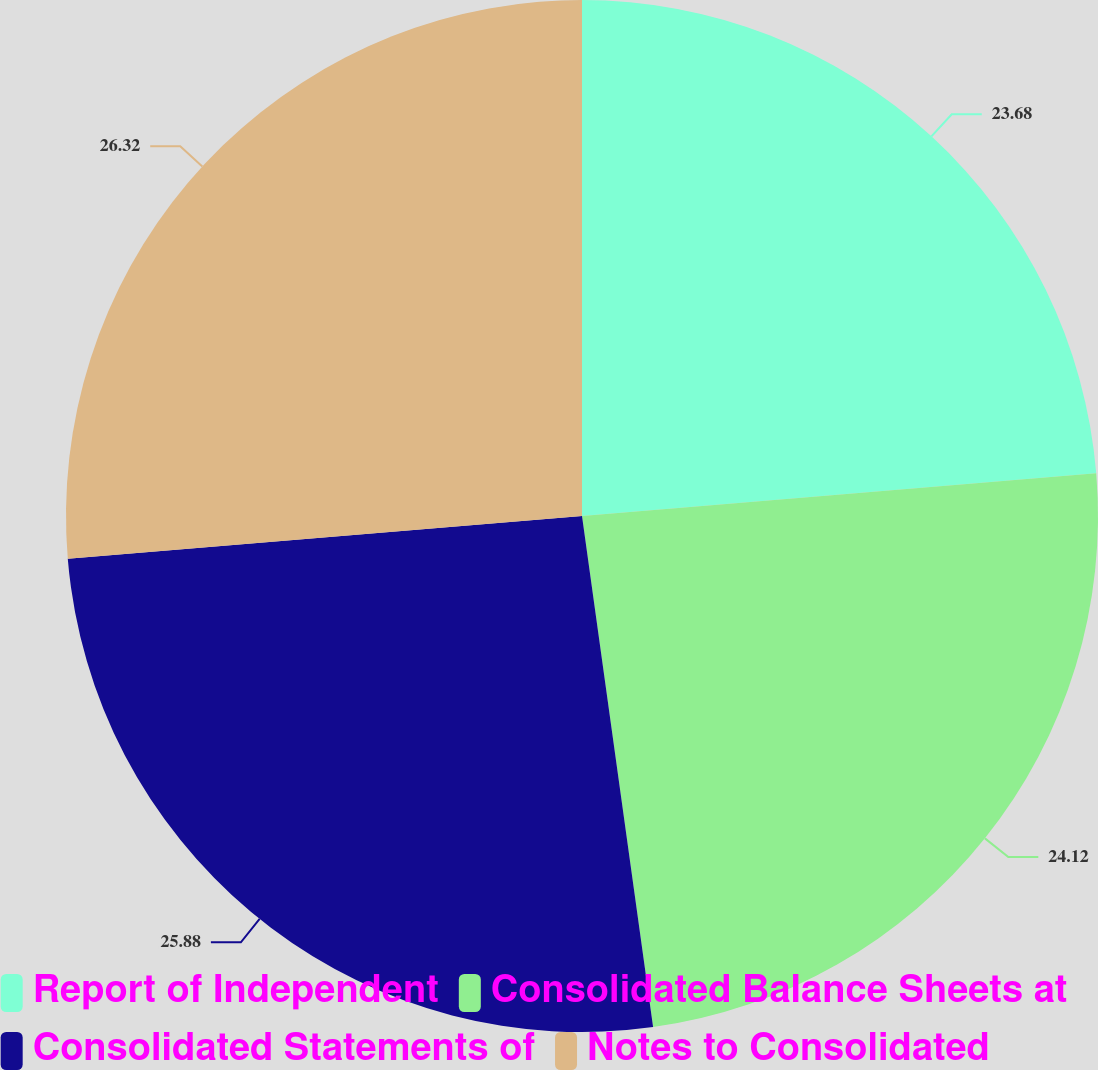<chart> <loc_0><loc_0><loc_500><loc_500><pie_chart><fcel>Report of Independent<fcel>Consolidated Balance Sheets at<fcel>Consolidated Statements of<fcel>Notes to Consolidated<nl><fcel>23.68%<fcel>24.12%<fcel>25.88%<fcel>26.32%<nl></chart> 